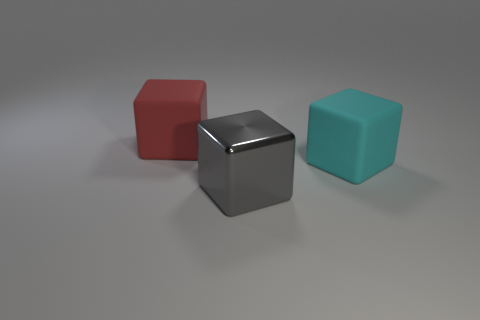Subtract all large matte blocks. How many blocks are left? 1 Add 3 gray cubes. How many objects exist? 6 Add 3 metal objects. How many metal objects are left? 4 Add 1 gray blocks. How many gray blocks exist? 2 Subtract 0 purple balls. How many objects are left? 3 Subtract all red cubes. Subtract all big cyan blocks. How many objects are left? 1 